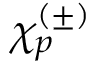<formula> <loc_0><loc_0><loc_500><loc_500>\chi _ { p } ^ { ( \pm ) }</formula> 